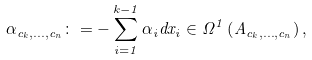<formula> <loc_0><loc_0><loc_500><loc_500>\alpha _ { c _ { k } , \dots , c _ { n } } \colon = - \sum _ { i = 1 } ^ { k - 1 } \alpha _ { i } d x _ { i } \in \Omega ^ { 1 } \left ( A _ { c _ { k } , \dots , c _ { n } } \right ) ,</formula> 